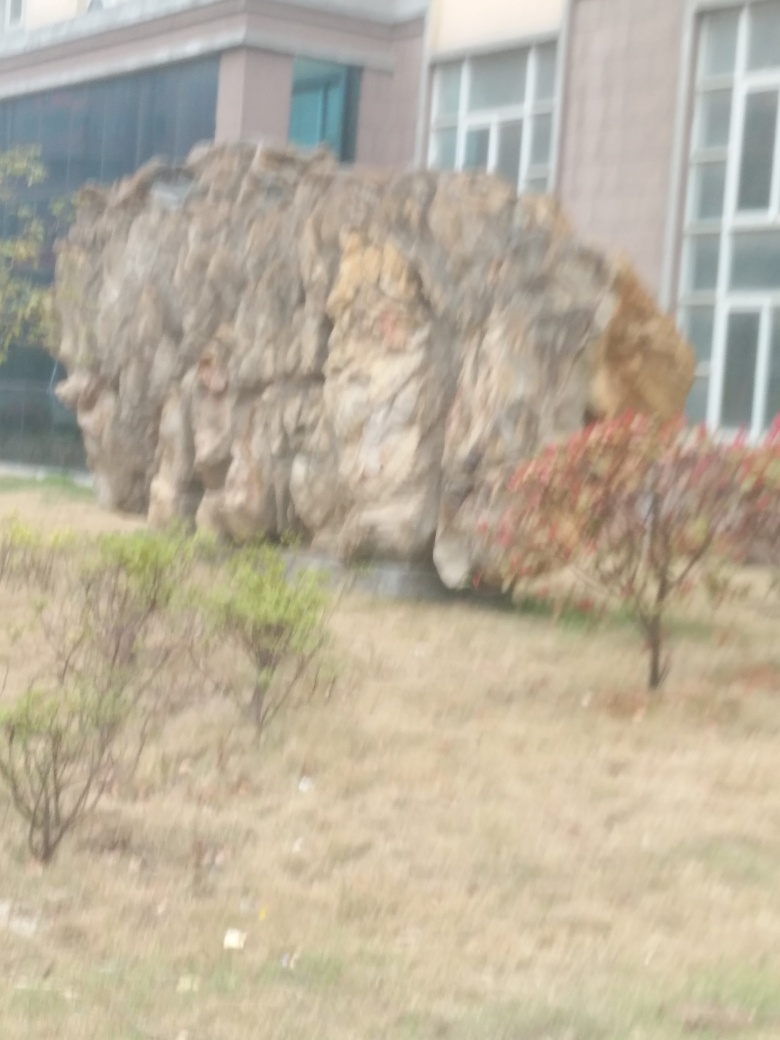Can you describe the surroundings of the main subject in the image? The main subject, which appears to be a sizable, irregularly shaped boulder, is situated in an open area with a stretch of grass around it. In the immediate vicinity, there are some small shrubs or bushes, and further back, a building with large windows can be seen, suggesting an urban park or garden setting. 